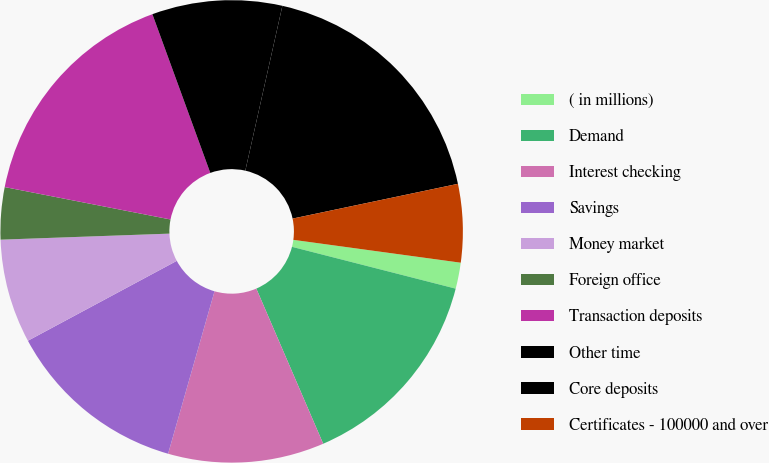<chart> <loc_0><loc_0><loc_500><loc_500><pie_chart><fcel>( in millions)<fcel>Demand<fcel>Interest checking<fcel>Savings<fcel>Money market<fcel>Foreign office<fcel>Transaction deposits<fcel>Other time<fcel>Core deposits<fcel>Certificates - 100000 and over<nl><fcel>1.82%<fcel>14.54%<fcel>10.91%<fcel>12.73%<fcel>7.27%<fcel>3.64%<fcel>16.36%<fcel>9.09%<fcel>18.18%<fcel>5.46%<nl></chart> 